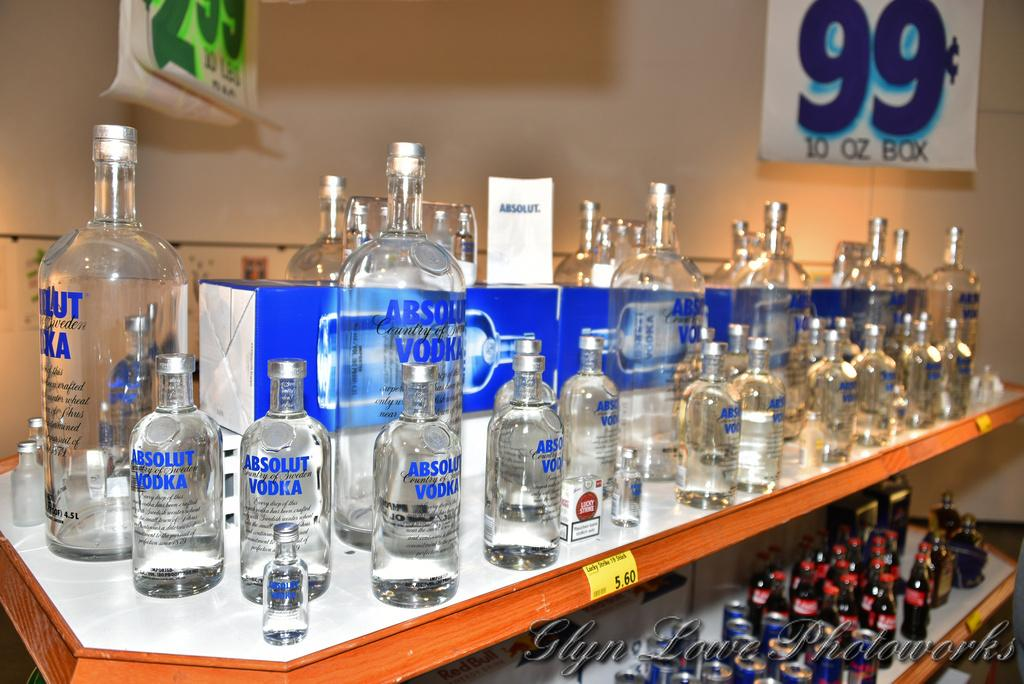<image>
Offer a succinct explanation of the picture presented. A shelf full of Absolut Vodka bottles for sale. 